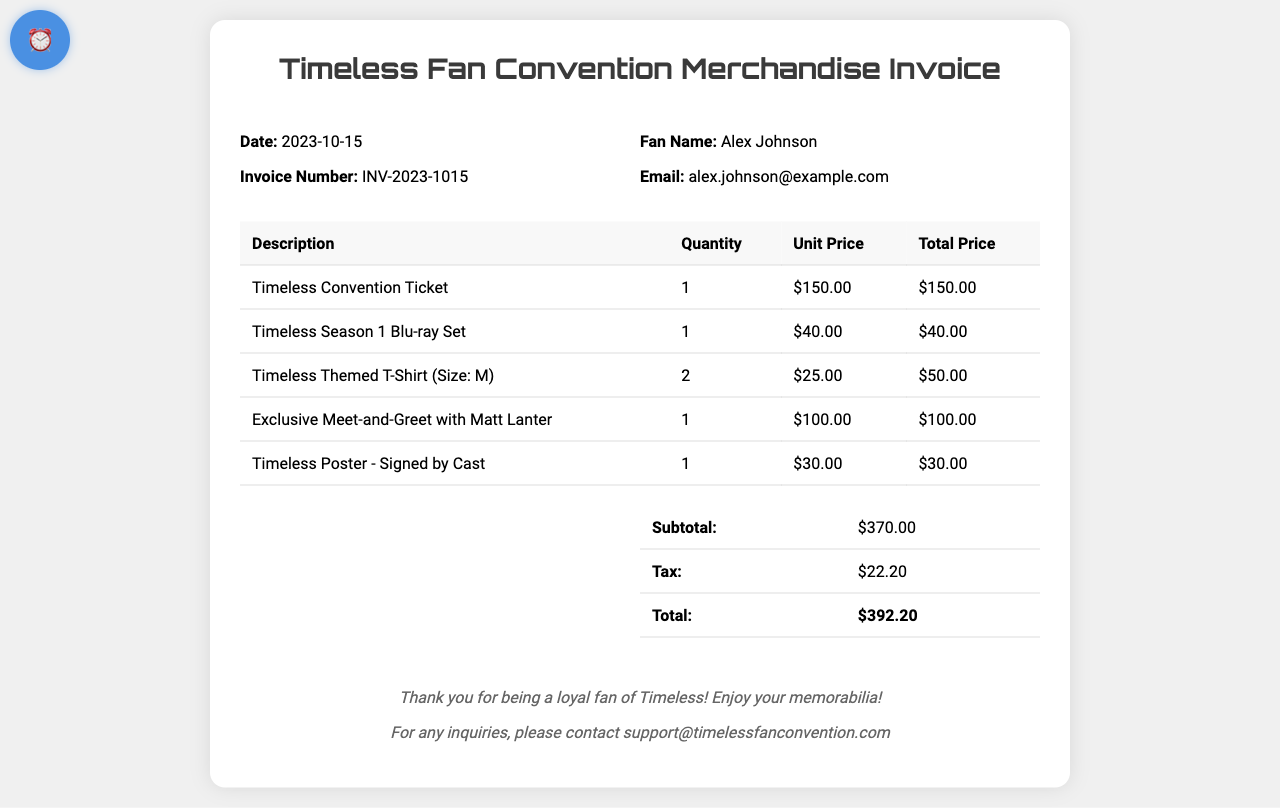What is the date of the invoice? The date of the invoice is explicitly stated in the document.
Answer: 2023-10-15 Who is the fan named in the invoice? The name of the fan is provided in the invoice details section.
Answer: Alex Johnson What is the total price of the Timeless Season 1 Blu-ray Set? The total price for this item is calculated from the unit price and quantity in the table.
Answer: $40.00 How many Timeless Themed T-Shirts were purchased? The quantity of the T-Shirts is listed in the merchandise table.
Answer: 2 What is the subtotal amount listed in the invoice? The invoice clearly states the subtotal before tax and fees.
Answer: $370.00 What is the tax amount applied to the invoice? The tax amount is explicitly mentioned in the summary section of the invoice.
Answer: $22.20 What item corresponds to the quantity of 1 in the invoice? There are several items listed with a quantity of 1, requiring reference to the invoice for confirmation.
Answer: Timeless Convention Ticket What is the total amount due on the invoice? The total amount is calculated by adding the subtotal and tax, shown in the summary.
Answer: $392.20 Which exclusive experience is mentioned in the invoice? The document lists an exclusive experience in the merchandise table.
Answer: Exclusive Meet-and-Greet with Matt Lanter 